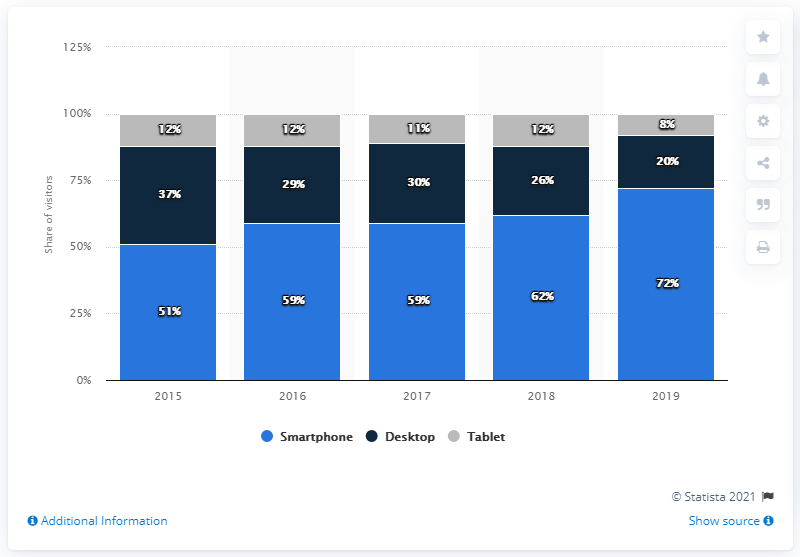List a handful of essential elements in this visual. In 2018, the difference between desktop usage and 2015 was 11%. In 2019, the most popular device was the smartphone. 